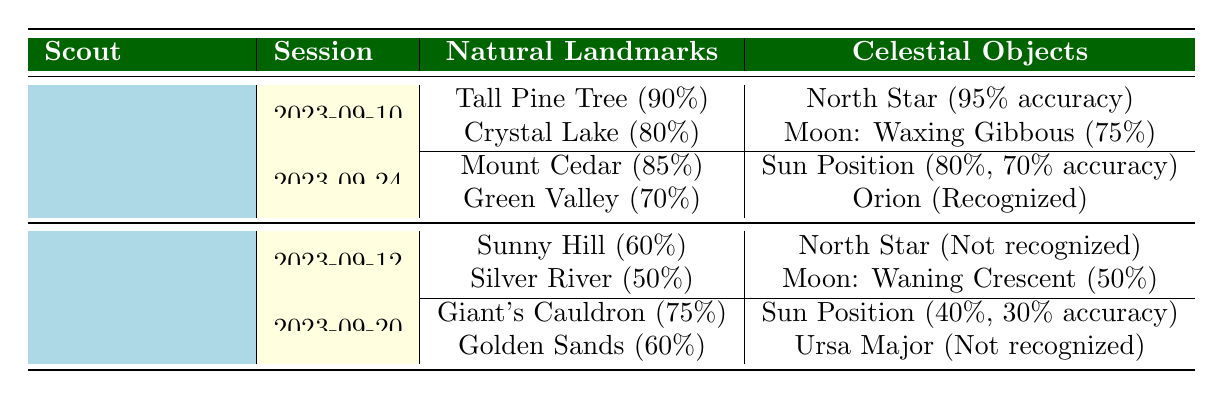What is the skill level of Alice Johnson? In the table, under the "Scout" section for Alice Johnson, there is a specific column indicating her skill level. The entry states "Intermediate."
Answer: Intermediate What was the success rate for the landmark "Tall Pine Tree"? The success rate for the "Tall Pine Tree," listed under Alice Johnson's first training session on 2023-09-10, is provided as 90%.
Answer: 90% Did Daniel Smith recognize the North Star in his first training session? The table shows that during Daniel Smith's first session on 2023-09-12, the North Star was marked as "Not recognized," indicating he did not recognize it.
Answer: No What is the average success rate of natural landmarks for Alice Johnson? Alice Johnson has two sessions, and the success rates for her natural landmarks are 90%, 80%, 85%, and 70%. Adding these gives 90 + 80 + 85 + 70 = 325. There are four landmarks, so the average would be 325/4 = 81.25.
Answer: 81.25 Which celestial object had the highest accuracy for Alice Johnson? In Alice Johnson's training sessions, the accuracy values are 95% for the North Star, 75% for the Moon, and 70% for the Sun. Among these, 95% for the North Star is the highest.
Answer: North Star What is the percentage difference in success rates for Daniel Smith's first and second sessions' natural landmarks? In Daniel Smith's first session, the success rates were 60% (Sunny Hill) and 50% (Silver River). In the second session, they were 75% (Giant's Cauldron) and 60% (Golden Sands). The average success rate for the first session is (60 + 50) / 2 = 55%. For the second session, it is (75 + 60) / 2 = 67.5%. The percentage difference is (67.5 - 55) / 55 * 100 = 22.73%.
Answer: 22.73% What features need improvement for Daniel Smith based on his sessions? Looking at Daniel Smith's data, he had low success rates and recognition rates in both sessions. Natural landmark success rates were lower than 60% in his first session, and he did not recognize the North Star or Ursa Major. These factors suggest he needs more training with natural landmarks and celestial recognition.
Answer: Needs improvement in natural landmarks and celestial objects recognition Which scout achieved the highest success rate for natural landmarks in their second session? Comparing the success rates from the second sessions, Alice Johnson's rates were 85% and 70%, while Daniel Smith's were 75% and 60%. Alice has a higher rate of 85%, making her the scout with the highest success in that category.
Answer: Alice Johnson How many celestial objects did Daniel Smith recognize across both training sessions? Daniel Smith did not recognize the North Star in his first session and also failed to recognize Ursa Major in his second session. Therefore, he recognized zero celestial objects over both sessions.
Answer: 0 